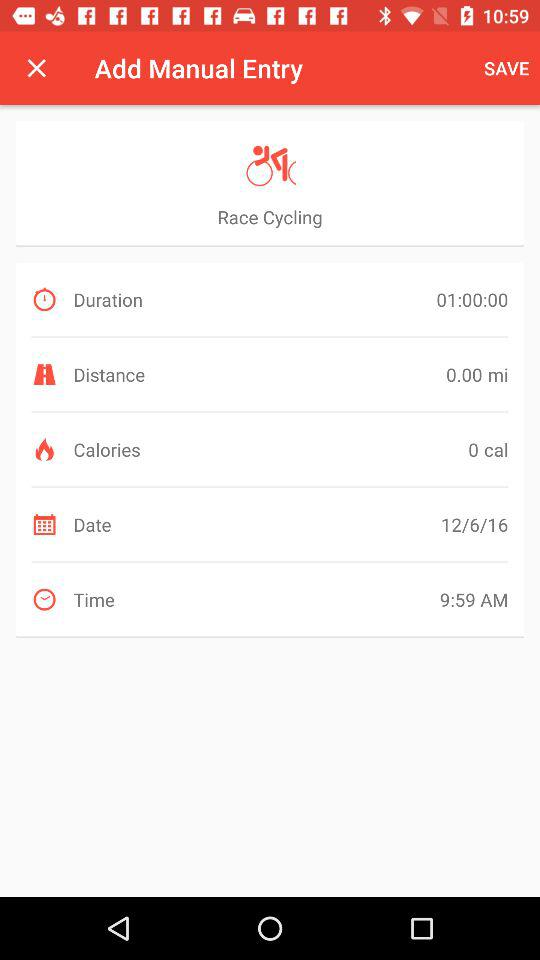What is the total time of the exercise?
Answer the question using a single word or phrase. 01:00:00 